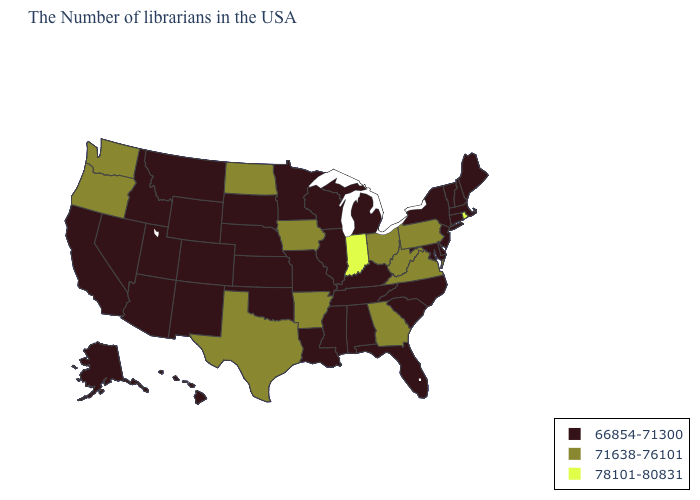What is the value of Iowa?
Quick response, please. 71638-76101. What is the value of California?
Short answer required. 66854-71300. How many symbols are there in the legend?
Write a very short answer. 3. Name the states that have a value in the range 71638-76101?
Give a very brief answer. Pennsylvania, Virginia, West Virginia, Ohio, Georgia, Arkansas, Iowa, Texas, North Dakota, Washington, Oregon. Name the states that have a value in the range 78101-80831?
Keep it brief. Rhode Island, Indiana. What is the lowest value in states that border Nevada?
Short answer required. 66854-71300. Does Maryland have the lowest value in the USA?
Short answer required. Yes. What is the lowest value in states that border Oklahoma?
Quick response, please. 66854-71300. Name the states that have a value in the range 71638-76101?
Answer briefly. Pennsylvania, Virginia, West Virginia, Ohio, Georgia, Arkansas, Iowa, Texas, North Dakota, Washington, Oregon. Does Louisiana have a lower value than Ohio?
Be succinct. Yes. What is the lowest value in the USA?
Keep it brief. 66854-71300. What is the value of New Mexico?
Quick response, please. 66854-71300. Name the states that have a value in the range 71638-76101?
Answer briefly. Pennsylvania, Virginia, West Virginia, Ohio, Georgia, Arkansas, Iowa, Texas, North Dakota, Washington, Oregon. Name the states that have a value in the range 71638-76101?
Answer briefly. Pennsylvania, Virginia, West Virginia, Ohio, Georgia, Arkansas, Iowa, Texas, North Dakota, Washington, Oregon. 